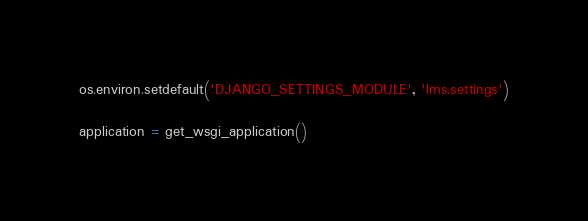<code> <loc_0><loc_0><loc_500><loc_500><_Python_>
os.environ.setdefault('DJANGO_SETTINGS_MODULE', 'lms.settings')

application = get_wsgi_application()
</code> 